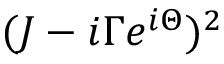Convert formula to latex. <formula><loc_0><loc_0><loc_500><loc_500>( J - i \Gamma e ^ { i \Theta } ) ^ { 2 }</formula> 